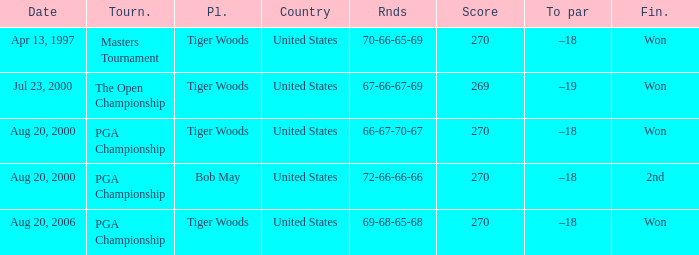What is the worst (highest) score? 270.0. 